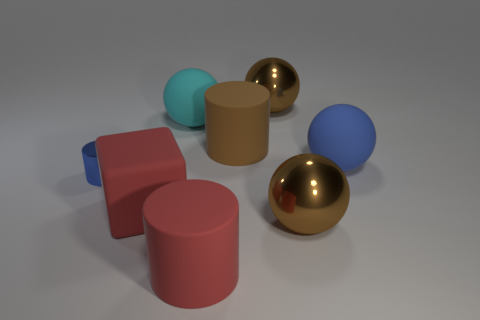Add 1 small red balls. How many objects exist? 9 Subtract all cylinders. How many objects are left? 5 Add 4 red objects. How many red objects are left? 6 Add 8 red blocks. How many red blocks exist? 9 Subtract 0 red spheres. How many objects are left? 8 Subtract all big cyan rubber objects. Subtract all large red rubber objects. How many objects are left? 5 